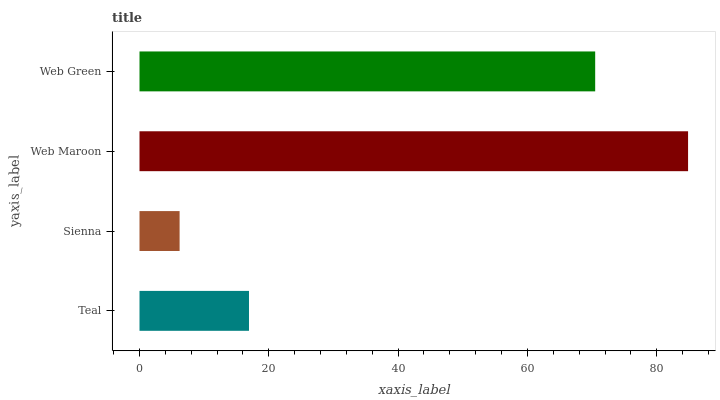Is Sienna the minimum?
Answer yes or no. Yes. Is Web Maroon the maximum?
Answer yes or no. Yes. Is Web Maroon the minimum?
Answer yes or no. No. Is Sienna the maximum?
Answer yes or no. No. Is Web Maroon greater than Sienna?
Answer yes or no. Yes. Is Sienna less than Web Maroon?
Answer yes or no. Yes. Is Sienna greater than Web Maroon?
Answer yes or no. No. Is Web Maroon less than Sienna?
Answer yes or no. No. Is Web Green the high median?
Answer yes or no. Yes. Is Teal the low median?
Answer yes or no. Yes. Is Web Maroon the high median?
Answer yes or no. No. Is Sienna the low median?
Answer yes or no. No. 